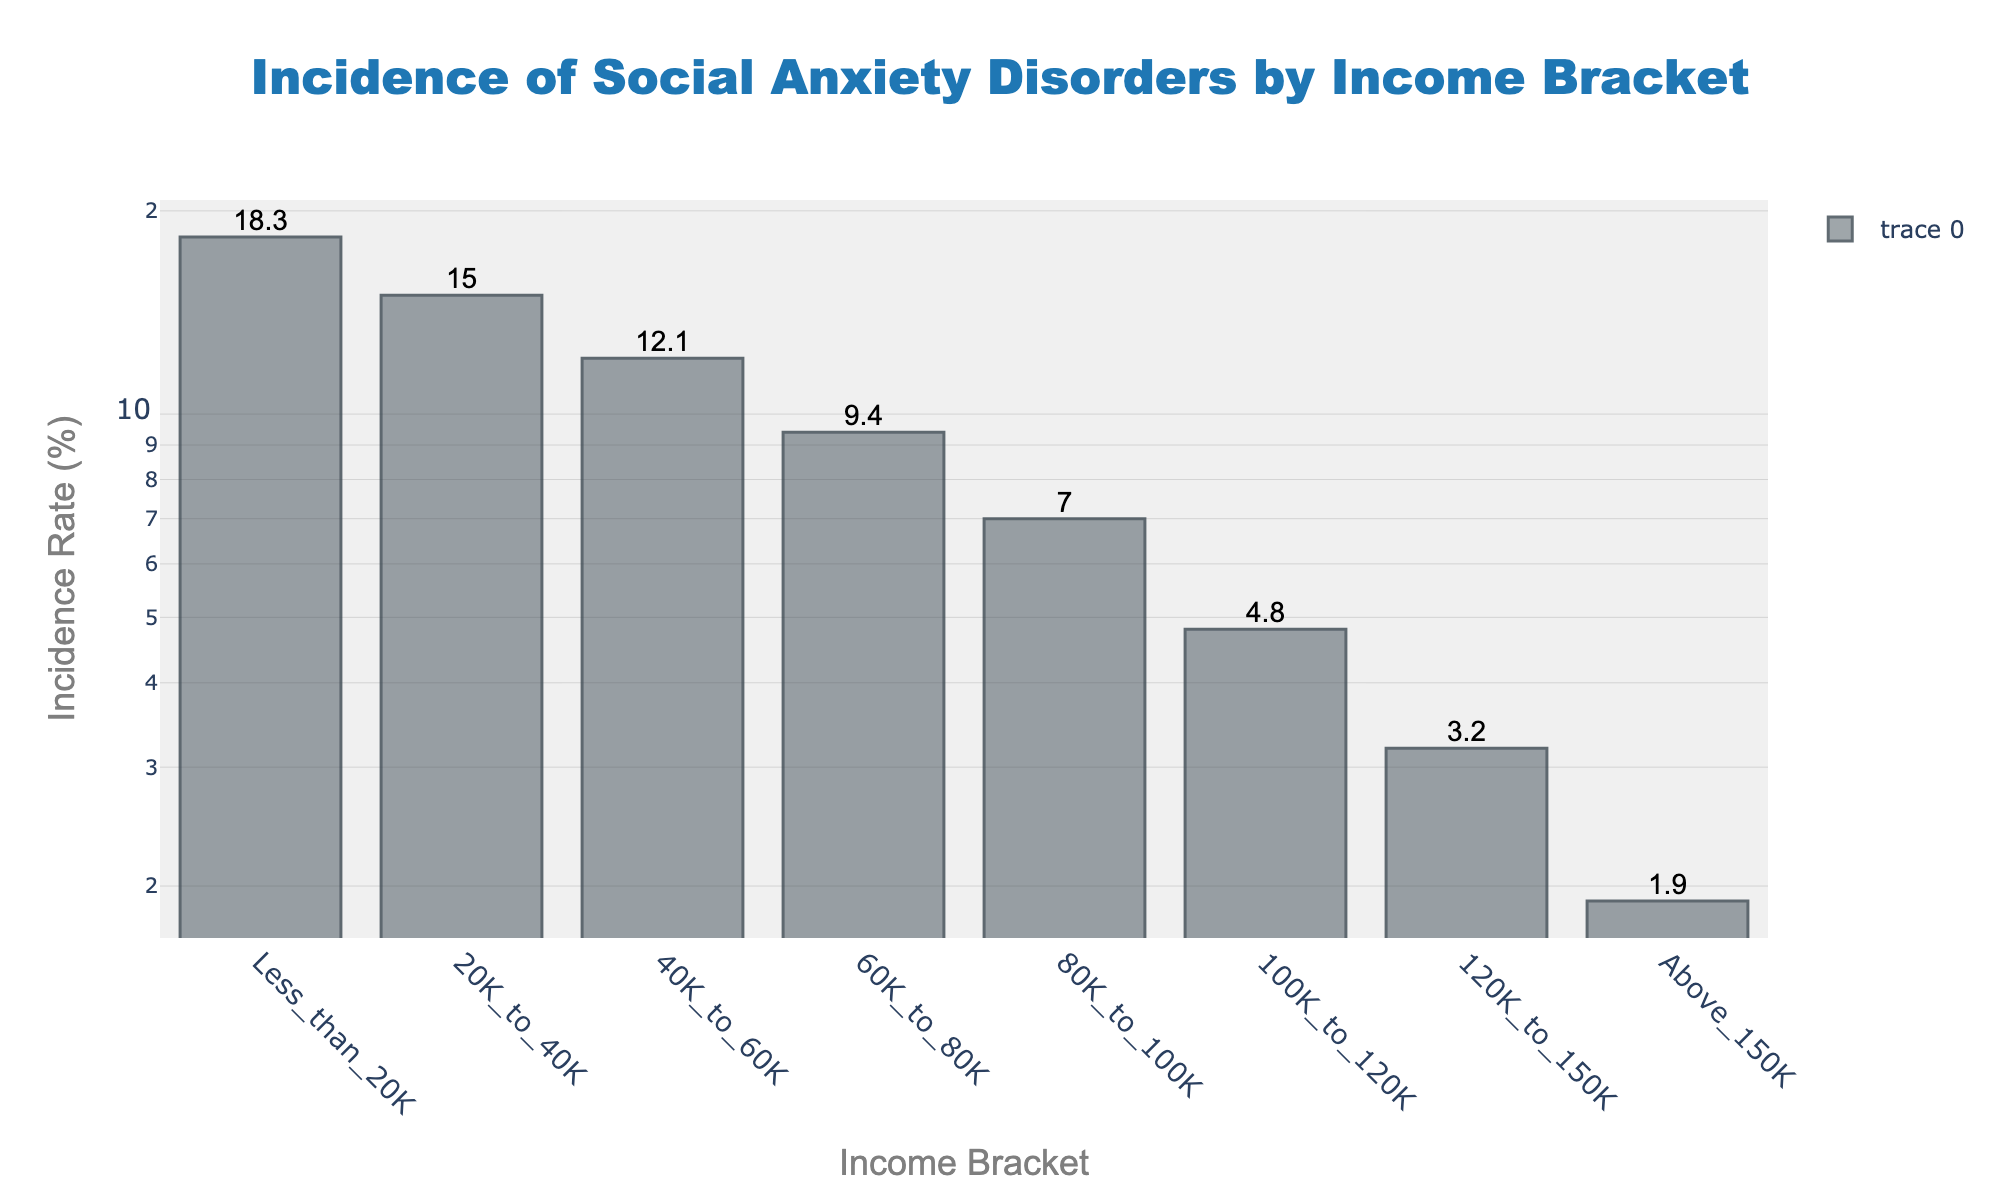What is the title of the figure? The title is displayed at the top center of the figure, above the bars. It reads "Incidence of Social Anxiety Disorders by Income Bracket".
Answer: Incidence of Social Anxiety Disorders by Income Bracket How many income brackets are displayed in the figure? The bars in the figure represent different income brackets. Counting the bars or checking the x-axis labels shows there are 8 income brackets.
Answer: 8 Which income bracket has the highest incidence rate of social anxiety disorders? The highest point on the y-axis corresponds to the "Less than 20K" income bracket. This can be identified by the height of the bar for that income bracket.
Answer: Less than 20K What is the incidence rate of social anxiety disorders for the 40K to 60K income bracket? Checking the bar for the "40K to 60K" income bracket on the x-axis shows the incidence rate listed at the top. The rate for this bracket is 12.1%.
Answer: 12.1% How much higher is the incidence rate in the "Less than 20K" bracket compared to the "Above 150K" bracket? To find the difference, subtract the incidence rate of the "Above 150K" bracket (1.9%) from the "Less than 20K" bracket (18.3%).
Answer: 16.4% Which income bracket has an incidence rate less than 10% but higher than 7%? The bars corresponding to income brackets that fall in this range on the y-axis need to be identified. The "60K to 80K" income bracket has a rate of 9.4%, fitting the description.
Answer: 60K to 80K On a log scale axis, which income bracketing shows an incidence rate lower than that of the 60K to 80K bracket but higher than the 20K to 40K bracket? On the log scale, the "40K to 60K" bracket has a rate lower than "60K to 80K" (9.4%) and in the same range as "20K to 40K" (15.0%), thus fitting the description.
Answer: 40K to 60K Is the incidence rate consistently declining as income increases? Analyzing the height of the bars from lower to higher income brackets shows a consistent decrease in the incidence rate, confirming a negative correlation between income and incidence rate.
Answer: Yes What is the difference in incidence rate between the 80K to 100K and 100K to 120K brackets? Subtract the incidence rate of the "100K to 120K" bracket (4.8%) from the "80K to 100K" bracket (7.0%).
Answer: 2.2% What general trend can you observe about the incidence rate of social anxiety disorders as income levels increase? Observing the plot, one can see a clear trend where the incidence rate of social anxiety disorders decreases as the income levels go higher.
Answer: Incidence rate decreases with increasing income 